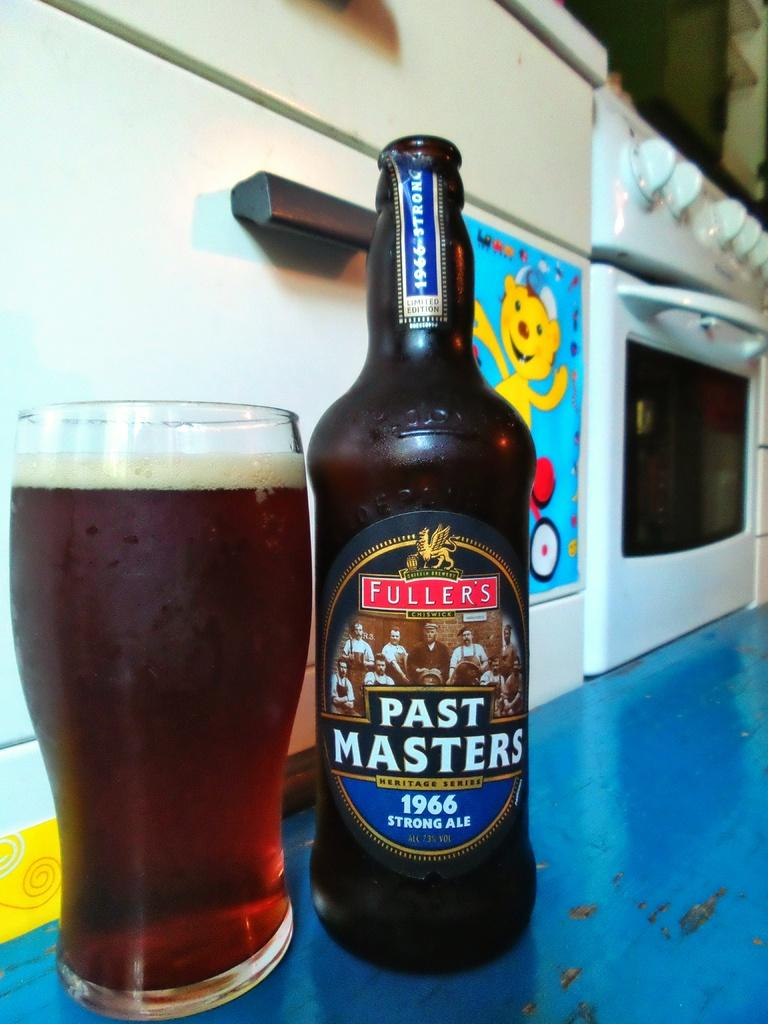<image>
Give a short and clear explanation of the subsequent image. A glass of beer sits next to the bottle, which is labelled Past Masters. 